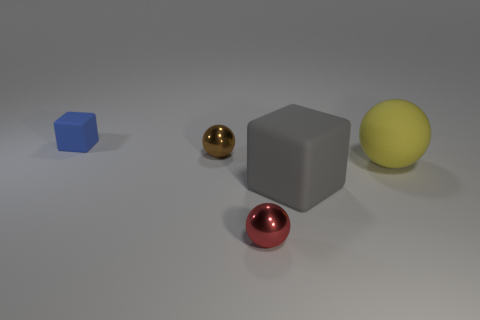Are there any yellow rubber spheres on the left side of the shiny sphere that is to the left of the red ball?
Provide a succinct answer. No. Is the number of big matte balls that are on the right side of the large yellow thing less than the number of large blocks that are right of the small red shiny sphere?
Keep it short and to the point. Yes. Do the block that is in front of the tiny blue matte cube and the ball that is to the right of the small red thing have the same material?
Provide a short and direct response. Yes. How many big objects are gray things or matte spheres?
Offer a terse response. 2. There is a large yellow object that is the same material as the small blue object; what shape is it?
Provide a succinct answer. Sphere. Is the number of big rubber objects that are behind the blue matte object less than the number of small gray matte spheres?
Your response must be concise. No. Do the tiny red thing and the big gray matte thing have the same shape?
Offer a very short reply. No. How many metallic objects are either tiny balls or green blocks?
Your answer should be compact. 2. Is there a shiny ball that has the same size as the blue matte cube?
Make the answer very short. Yes. How many blue metallic spheres have the same size as the yellow rubber thing?
Provide a short and direct response. 0. 